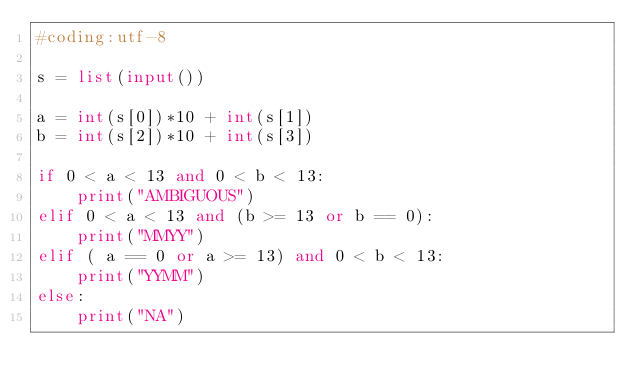<code> <loc_0><loc_0><loc_500><loc_500><_Python_>#coding:utf-8

s = list(input())

a = int(s[0])*10 + int(s[1])
b = int(s[2])*10 + int(s[3])

if 0 < a < 13 and 0 < b < 13:
    print("AMBIGUOUS")
elif 0 < a < 13 and (b >= 13 or b == 0):
    print("MMYY")
elif ( a == 0 or a >= 13) and 0 < b < 13:
    print("YYMM")
else:
    print("NA")</code> 